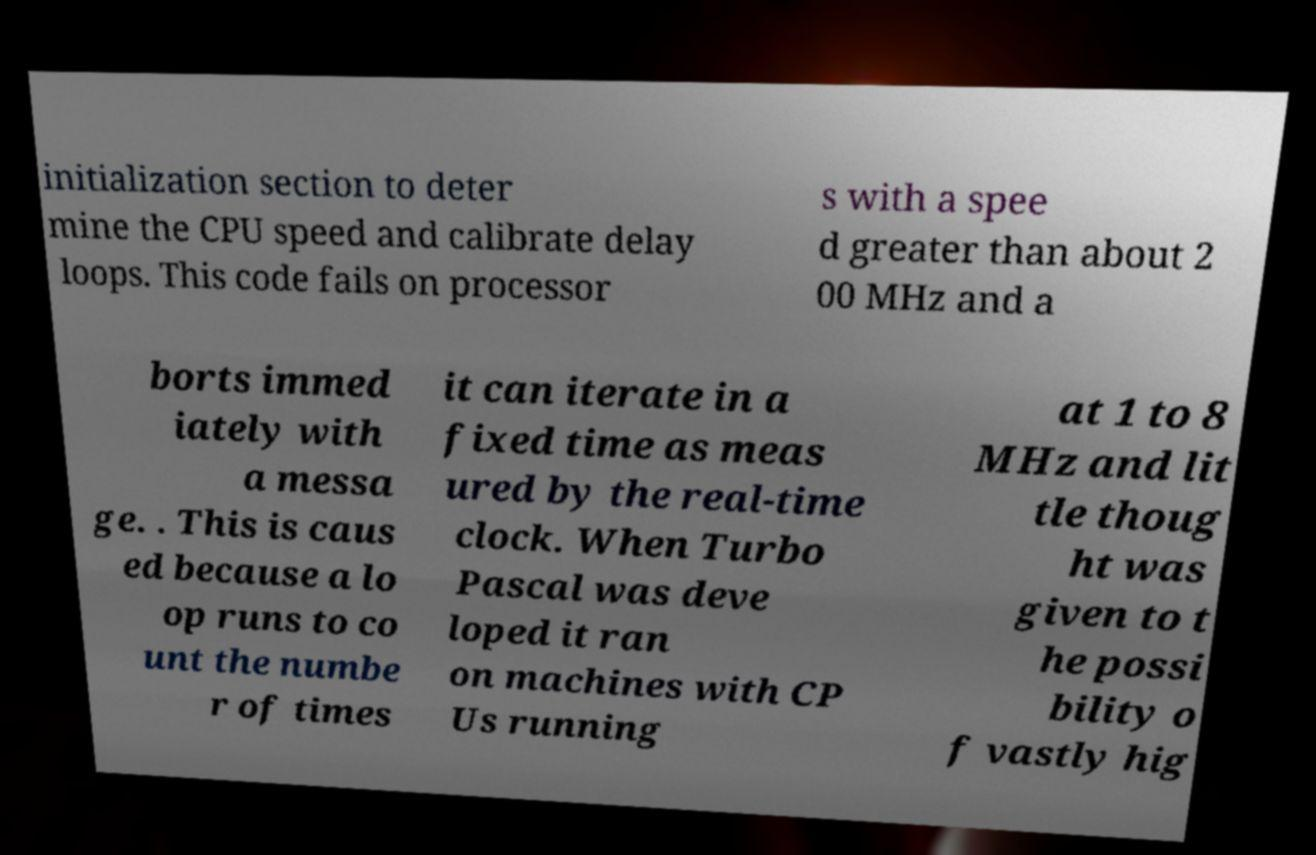Could you assist in decoding the text presented in this image and type it out clearly? initialization section to deter mine the CPU speed and calibrate delay loops. This code fails on processor s with a spee d greater than about 2 00 MHz and a borts immed iately with a messa ge. . This is caus ed because a lo op runs to co unt the numbe r of times it can iterate in a fixed time as meas ured by the real-time clock. When Turbo Pascal was deve loped it ran on machines with CP Us running at 1 to 8 MHz and lit tle thoug ht was given to t he possi bility o f vastly hig 